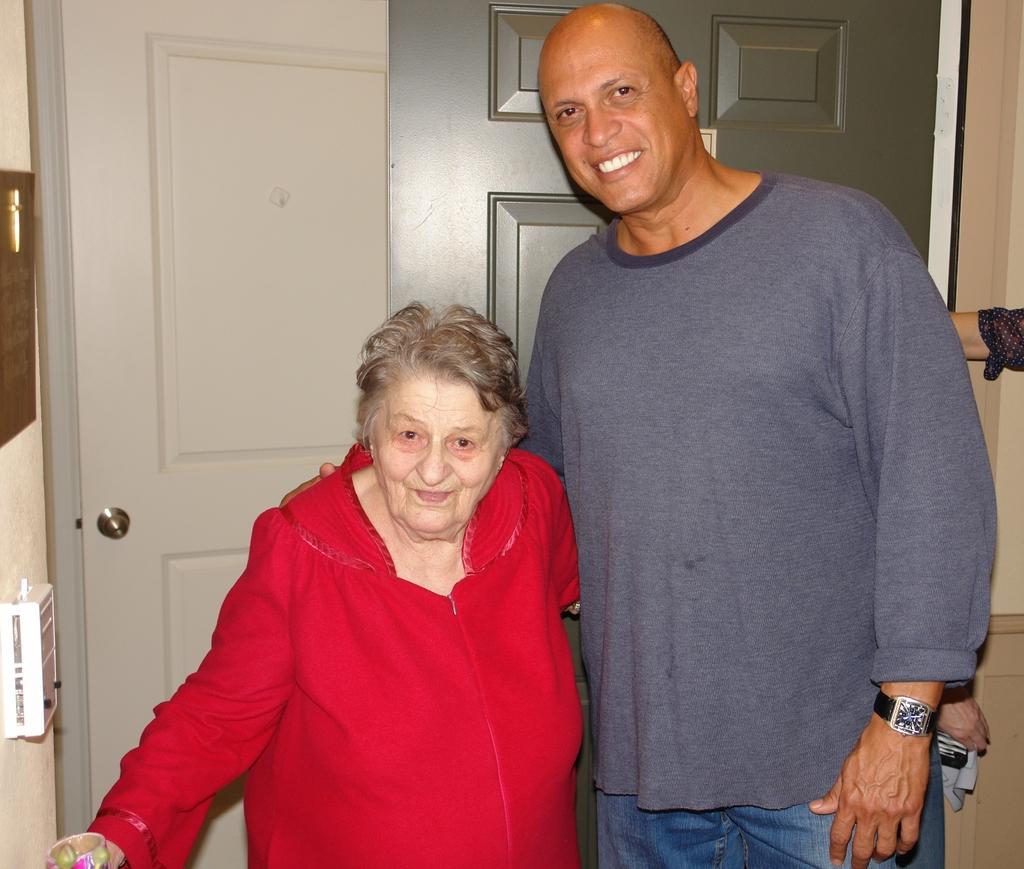Describe this image in one or two sentences. In the center of the image we can see two persons are standing and they are smiling, which we can see on their faces. And the woman is holding some object. In the background there is a wall, door, white box, golden color object and a few other objects. On the right side of the image, we can see one hand. 